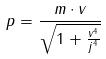Convert formula to latex. <formula><loc_0><loc_0><loc_500><loc_500>p = \frac { m \cdot v } { \sqrt { 1 + \frac { v ^ { 4 } } { j ^ { 4 } } } }</formula> 